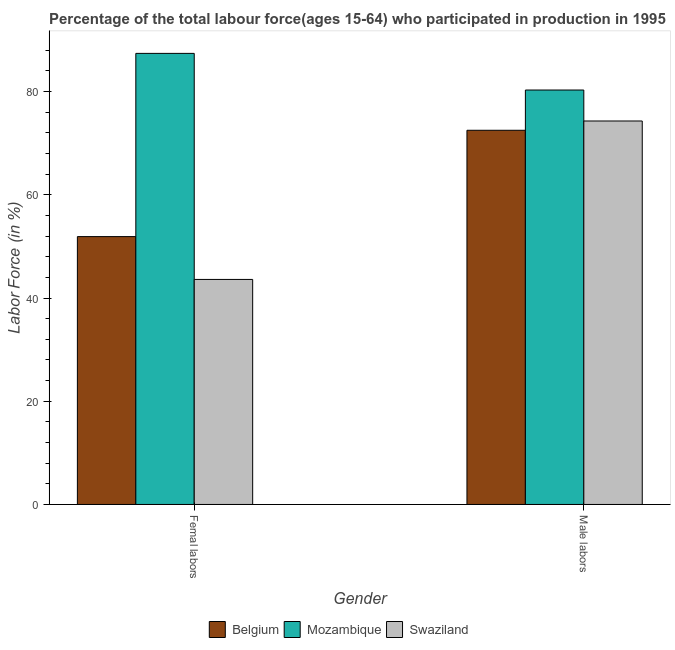How many different coloured bars are there?
Make the answer very short. 3. How many bars are there on the 1st tick from the left?
Your answer should be very brief. 3. What is the label of the 1st group of bars from the left?
Ensure brevity in your answer.  Femal labors. What is the percentage of male labour force in Swaziland?
Provide a succinct answer. 74.3. Across all countries, what is the maximum percentage of male labour force?
Offer a very short reply. 80.3. Across all countries, what is the minimum percentage of male labour force?
Offer a very short reply. 72.5. In which country was the percentage of female labor force maximum?
Your answer should be compact. Mozambique. What is the total percentage of female labor force in the graph?
Ensure brevity in your answer.  182.9. What is the difference between the percentage of male labour force in Swaziland and that in Mozambique?
Your answer should be very brief. -6. What is the difference between the percentage of male labour force in Swaziland and the percentage of female labor force in Belgium?
Provide a succinct answer. 22.4. What is the average percentage of male labour force per country?
Your answer should be compact. 75.7. What is the difference between the percentage of male labour force and percentage of female labor force in Mozambique?
Make the answer very short. -7.1. What is the ratio of the percentage of female labor force in Belgium to that in Mozambique?
Provide a succinct answer. 0.59. What does the 3rd bar from the left in Femal labors represents?
Your answer should be compact. Swaziland. How many countries are there in the graph?
Your answer should be compact. 3. What is the difference between two consecutive major ticks on the Y-axis?
Your answer should be compact. 20. Are the values on the major ticks of Y-axis written in scientific E-notation?
Your answer should be compact. No. Does the graph contain any zero values?
Offer a terse response. No. How many legend labels are there?
Provide a short and direct response. 3. What is the title of the graph?
Offer a terse response. Percentage of the total labour force(ages 15-64) who participated in production in 1995. What is the Labor Force (in %) in Belgium in Femal labors?
Provide a short and direct response. 51.9. What is the Labor Force (in %) of Mozambique in Femal labors?
Provide a short and direct response. 87.4. What is the Labor Force (in %) of Swaziland in Femal labors?
Your answer should be compact. 43.6. What is the Labor Force (in %) of Belgium in Male labors?
Your answer should be compact. 72.5. What is the Labor Force (in %) in Mozambique in Male labors?
Your response must be concise. 80.3. What is the Labor Force (in %) of Swaziland in Male labors?
Provide a short and direct response. 74.3. Across all Gender, what is the maximum Labor Force (in %) of Belgium?
Your response must be concise. 72.5. Across all Gender, what is the maximum Labor Force (in %) of Mozambique?
Your answer should be very brief. 87.4. Across all Gender, what is the maximum Labor Force (in %) in Swaziland?
Give a very brief answer. 74.3. Across all Gender, what is the minimum Labor Force (in %) of Belgium?
Provide a succinct answer. 51.9. Across all Gender, what is the minimum Labor Force (in %) of Mozambique?
Provide a short and direct response. 80.3. Across all Gender, what is the minimum Labor Force (in %) in Swaziland?
Make the answer very short. 43.6. What is the total Labor Force (in %) of Belgium in the graph?
Keep it short and to the point. 124.4. What is the total Labor Force (in %) in Mozambique in the graph?
Your answer should be compact. 167.7. What is the total Labor Force (in %) in Swaziland in the graph?
Your answer should be very brief. 117.9. What is the difference between the Labor Force (in %) of Belgium in Femal labors and that in Male labors?
Make the answer very short. -20.6. What is the difference between the Labor Force (in %) of Mozambique in Femal labors and that in Male labors?
Your answer should be compact. 7.1. What is the difference between the Labor Force (in %) of Swaziland in Femal labors and that in Male labors?
Offer a terse response. -30.7. What is the difference between the Labor Force (in %) in Belgium in Femal labors and the Labor Force (in %) in Mozambique in Male labors?
Ensure brevity in your answer.  -28.4. What is the difference between the Labor Force (in %) in Belgium in Femal labors and the Labor Force (in %) in Swaziland in Male labors?
Keep it short and to the point. -22.4. What is the average Labor Force (in %) in Belgium per Gender?
Keep it short and to the point. 62.2. What is the average Labor Force (in %) in Mozambique per Gender?
Ensure brevity in your answer.  83.85. What is the average Labor Force (in %) of Swaziland per Gender?
Offer a terse response. 58.95. What is the difference between the Labor Force (in %) in Belgium and Labor Force (in %) in Mozambique in Femal labors?
Keep it short and to the point. -35.5. What is the difference between the Labor Force (in %) of Mozambique and Labor Force (in %) of Swaziland in Femal labors?
Ensure brevity in your answer.  43.8. What is the difference between the Labor Force (in %) of Belgium and Labor Force (in %) of Mozambique in Male labors?
Your answer should be compact. -7.8. What is the difference between the Labor Force (in %) in Mozambique and Labor Force (in %) in Swaziland in Male labors?
Provide a short and direct response. 6. What is the ratio of the Labor Force (in %) in Belgium in Femal labors to that in Male labors?
Your answer should be compact. 0.72. What is the ratio of the Labor Force (in %) in Mozambique in Femal labors to that in Male labors?
Keep it short and to the point. 1.09. What is the ratio of the Labor Force (in %) of Swaziland in Femal labors to that in Male labors?
Provide a succinct answer. 0.59. What is the difference between the highest and the second highest Labor Force (in %) of Belgium?
Provide a short and direct response. 20.6. What is the difference between the highest and the second highest Labor Force (in %) of Swaziland?
Make the answer very short. 30.7. What is the difference between the highest and the lowest Labor Force (in %) in Belgium?
Provide a succinct answer. 20.6. What is the difference between the highest and the lowest Labor Force (in %) of Mozambique?
Make the answer very short. 7.1. What is the difference between the highest and the lowest Labor Force (in %) in Swaziland?
Give a very brief answer. 30.7. 